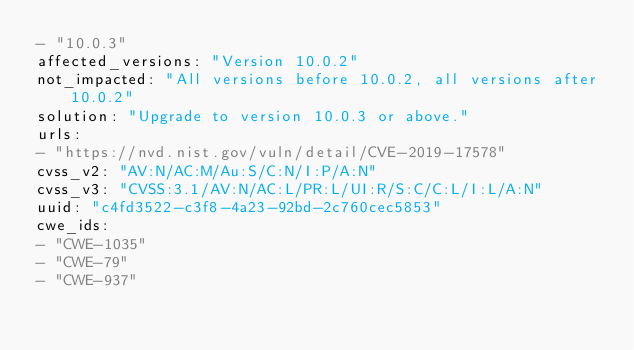Convert code to text. <code><loc_0><loc_0><loc_500><loc_500><_YAML_>- "10.0.3"
affected_versions: "Version 10.0.2"
not_impacted: "All versions before 10.0.2, all versions after 10.0.2"
solution: "Upgrade to version 10.0.3 or above."
urls:
- "https://nvd.nist.gov/vuln/detail/CVE-2019-17578"
cvss_v2: "AV:N/AC:M/Au:S/C:N/I:P/A:N"
cvss_v3: "CVSS:3.1/AV:N/AC:L/PR:L/UI:R/S:C/C:L/I:L/A:N"
uuid: "c4fd3522-c3f8-4a23-92bd-2c760cec5853"
cwe_ids:
- "CWE-1035"
- "CWE-79"
- "CWE-937"
</code> 